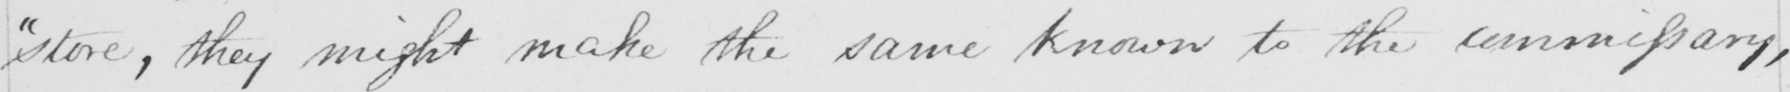Can you tell me what this handwritten text says? "store, they might make the same known to the commissary, 